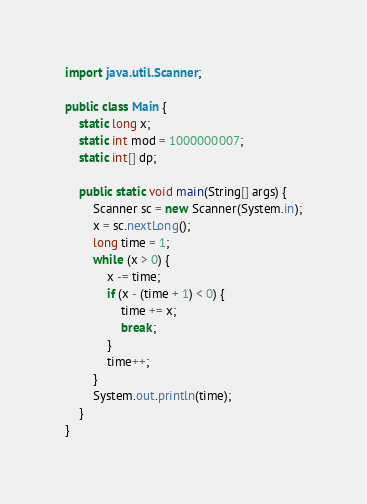Convert code to text. <code><loc_0><loc_0><loc_500><loc_500><_Java_>import java.util.Scanner;

public class Main {
    static long x;
    static int mod = 1000000007;
    static int[] dp;

    public static void main(String[] args) {
        Scanner sc = new Scanner(System.in);
        x = sc.nextLong();
        long time = 1;
        while (x > 0) {
            x -= time;
            if (x - (time + 1) < 0) {
                time += x;
                break;
            }
            time++;
        }
        System.out.println(time);
    }
}
</code> 